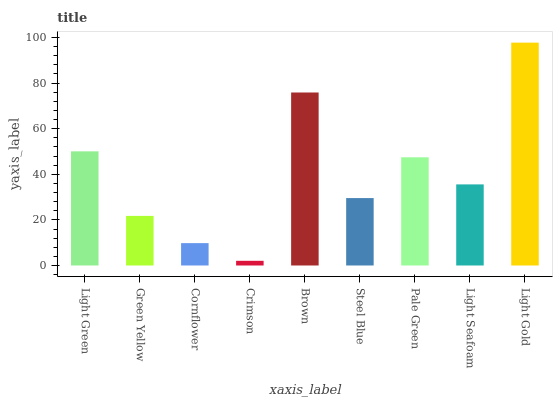Is Green Yellow the minimum?
Answer yes or no. No. Is Green Yellow the maximum?
Answer yes or no. No. Is Light Green greater than Green Yellow?
Answer yes or no. Yes. Is Green Yellow less than Light Green?
Answer yes or no. Yes. Is Green Yellow greater than Light Green?
Answer yes or no. No. Is Light Green less than Green Yellow?
Answer yes or no. No. Is Light Seafoam the high median?
Answer yes or no. Yes. Is Light Seafoam the low median?
Answer yes or no. Yes. Is Pale Green the high median?
Answer yes or no. No. Is Pale Green the low median?
Answer yes or no. No. 